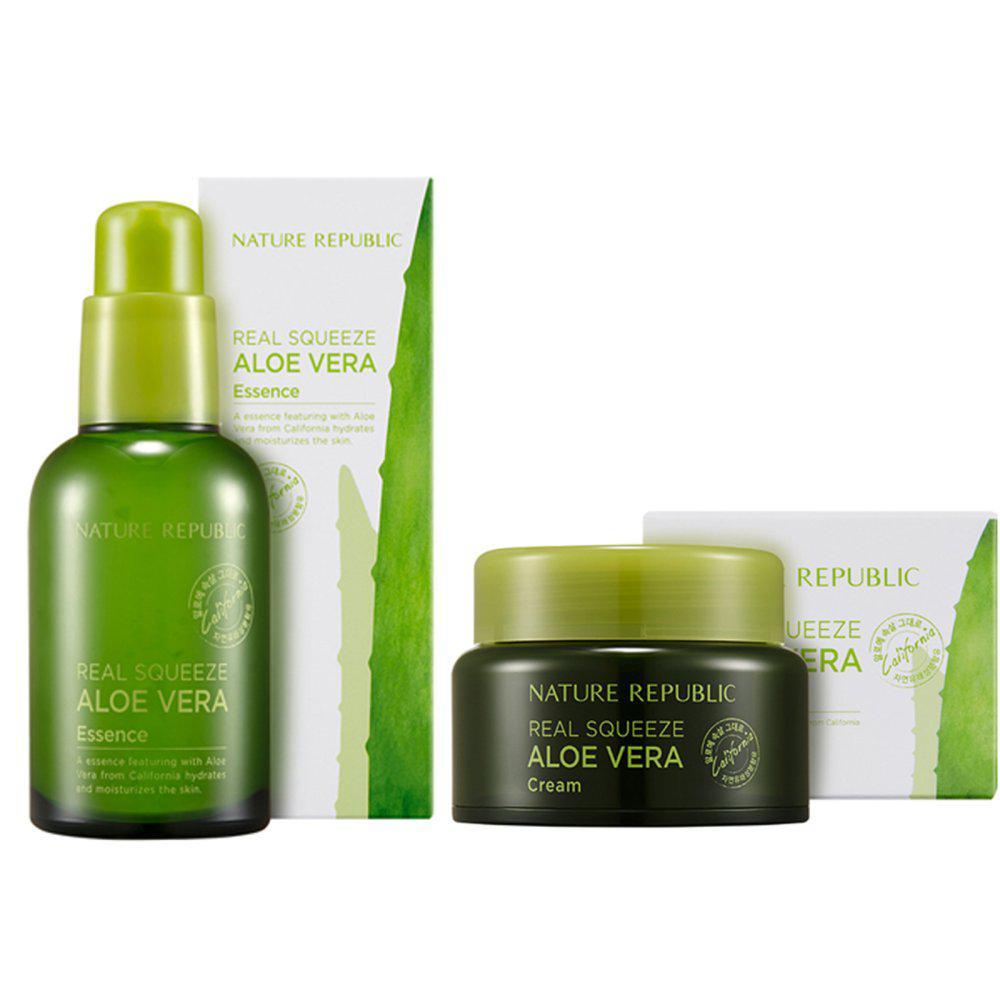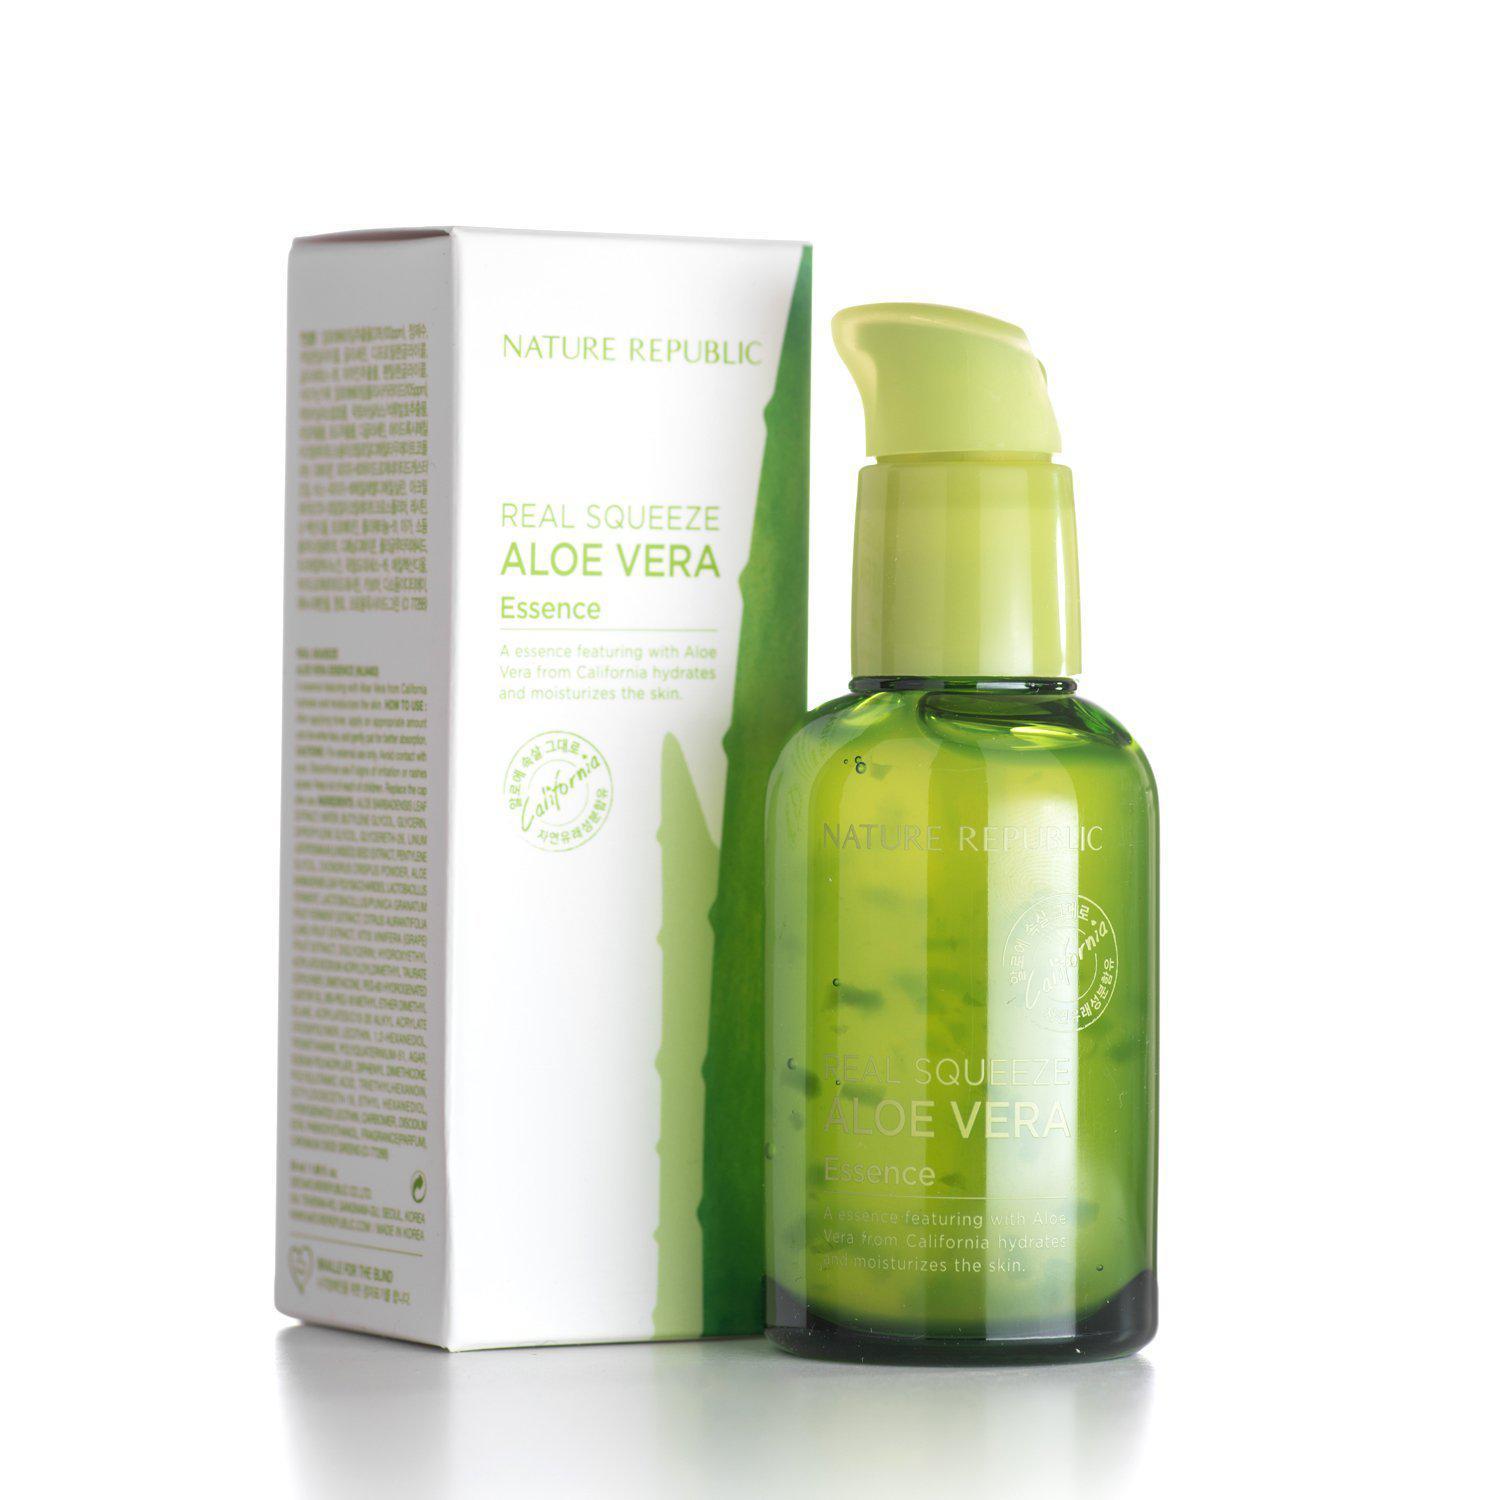The first image is the image on the left, the second image is the image on the right. For the images shown, is this caption "An image includes just one product next to a box: a green bottle without a white label." true? Answer yes or no. Yes. The first image is the image on the left, the second image is the image on the right. For the images shown, is this caption "There are two products in total in the pair of images." true? Answer yes or no. No. 